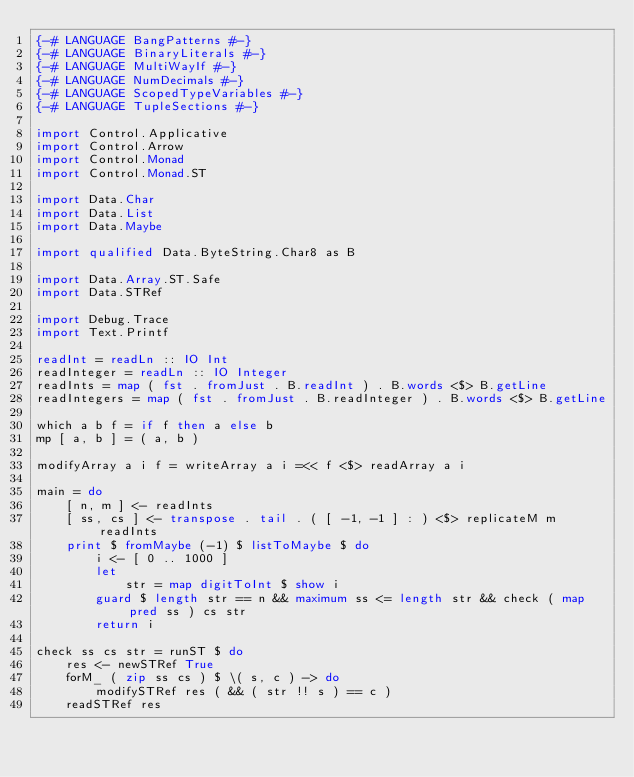<code> <loc_0><loc_0><loc_500><loc_500><_Haskell_>{-# LANGUAGE BangPatterns #-}
{-# LANGUAGE BinaryLiterals #-}
{-# LANGUAGE MultiWayIf #-}
{-# LANGUAGE NumDecimals #-}
{-# LANGUAGE ScopedTypeVariables #-}
{-# LANGUAGE TupleSections #-}

import Control.Applicative
import Control.Arrow
import Control.Monad
import Control.Monad.ST

import Data.Char
import Data.List
import Data.Maybe

import qualified Data.ByteString.Char8 as B

import Data.Array.ST.Safe
import Data.STRef

import Debug.Trace
import Text.Printf

readInt = readLn :: IO Int
readInteger = readLn :: IO Integer
readInts = map ( fst . fromJust . B.readInt ) . B.words <$> B.getLine
readIntegers = map ( fst . fromJust . B.readInteger ) . B.words <$> B.getLine

which a b f = if f then a else b
mp [ a, b ] = ( a, b )

modifyArray a i f = writeArray a i =<< f <$> readArray a i

main = do
	[ n, m ] <- readInts
	[ ss, cs ] <- transpose . tail . ( [ -1, -1 ] : ) <$> replicateM m readInts
	print $ fromMaybe (-1) $ listToMaybe $ do
		i <- [ 0 .. 1000 ]
		let
			str = map digitToInt $ show i
		guard $ length str == n && maximum ss <= length str && check ( map pred ss ) cs str
		return i

check ss cs str = runST $ do
	res <- newSTRef True
	forM_ ( zip ss cs ) $ \( s, c ) -> do
		modifySTRef res ( && ( str !! s ) == c )
	readSTRef res</code> 